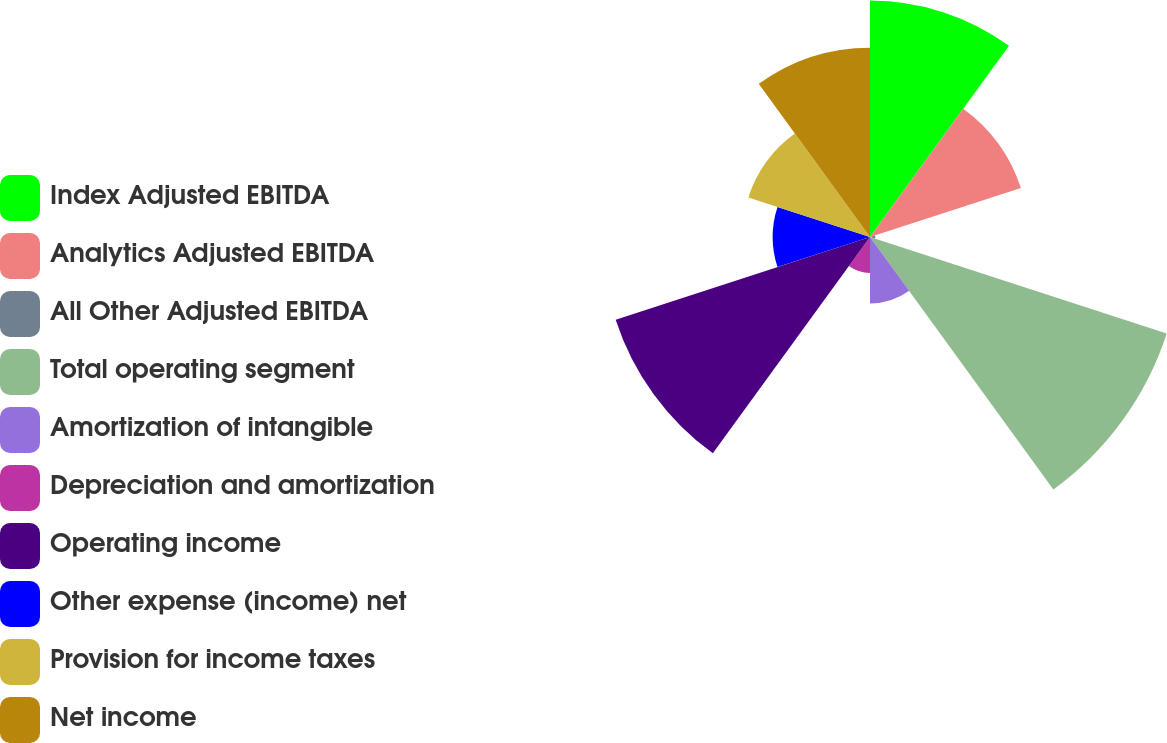Convert chart to OTSL. <chart><loc_0><loc_0><loc_500><loc_500><pie_chart><fcel>Index Adjusted EBITDA<fcel>Analytics Adjusted EBITDA<fcel>All Other Adjusted EBITDA<fcel>Total operating segment<fcel>Amortization of intangible<fcel>Depreciation and amortization<fcel>Operating income<fcel>Other expense (income) net<fcel>Provision for income taxes<fcel>Net income<nl><fcel>15.8%<fcel>10.6%<fcel>0.35%<fcel>20.85%<fcel>4.45%<fcel>2.4%<fcel>17.87%<fcel>6.5%<fcel>8.55%<fcel>12.65%<nl></chart> 